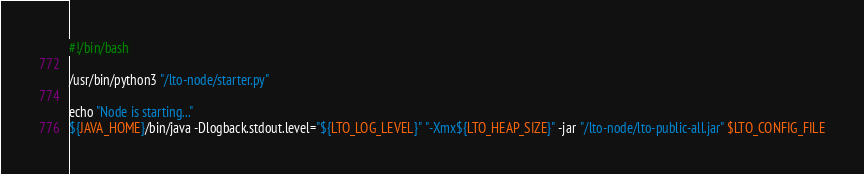Convert code to text. <code><loc_0><loc_0><loc_500><loc_500><_Bash_>#!/bin/bash

/usr/bin/python3 "/lto-node/starter.py"

echo "Node is starting..."
${JAVA_HOME}/bin/java -Dlogback.stdout.level="${LTO_LOG_LEVEL}" "-Xmx${LTO_HEAP_SIZE}" -jar "/lto-node/lto-public-all.jar" $LTO_CONFIG_FILE
</code> 